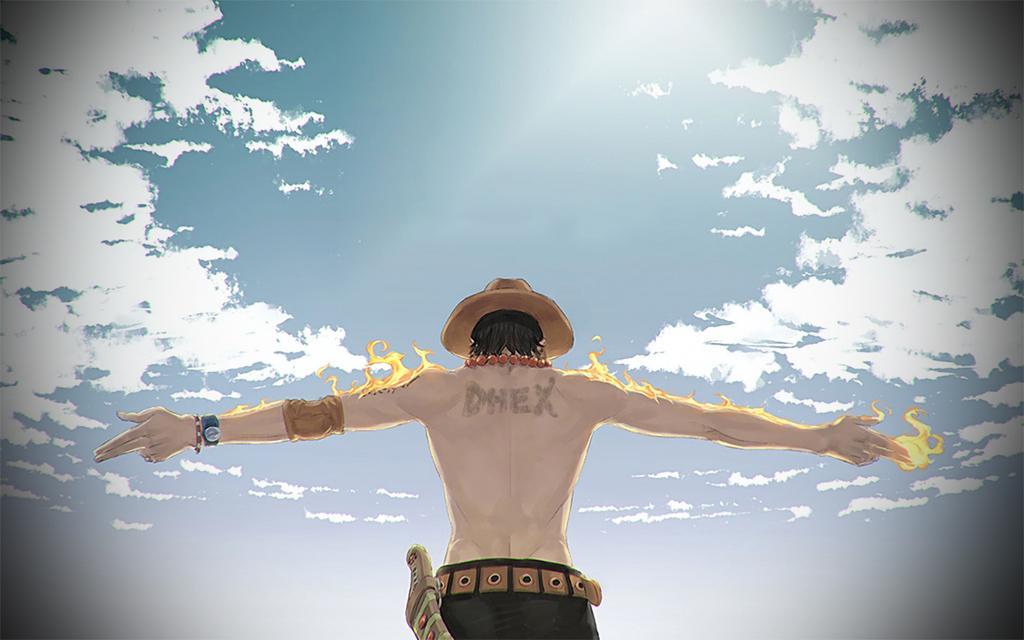Describe this image in one or two sentences. In this image there is an animated image of a man who is standing by raising his both hands. There is fire on his hands. At the top there is the sky. 